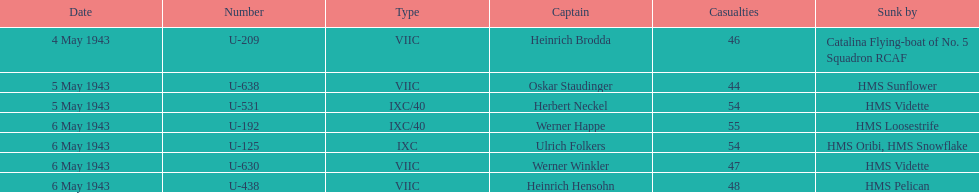Which submerged u-boat had the highest fatalities? U-192. 